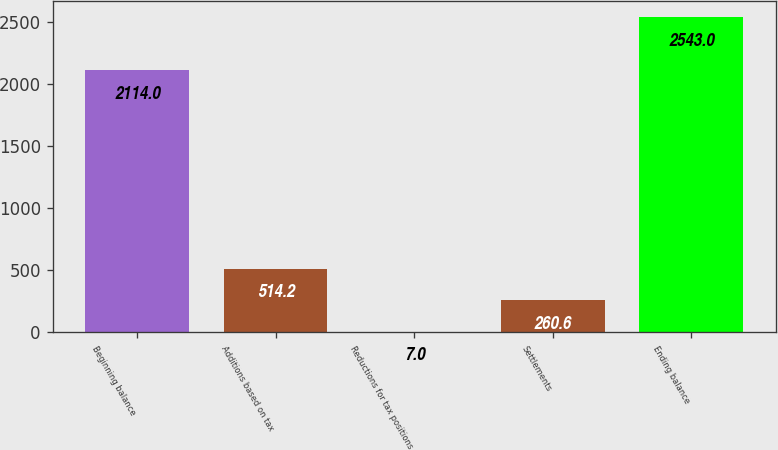Convert chart to OTSL. <chart><loc_0><loc_0><loc_500><loc_500><bar_chart><fcel>Beginning balance<fcel>Additions based on tax<fcel>Reductions for tax positions<fcel>Settlements<fcel>Ending balance<nl><fcel>2114<fcel>514.2<fcel>7<fcel>260.6<fcel>2543<nl></chart> 